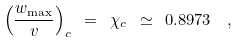Convert formula to latex. <formula><loc_0><loc_0><loc_500><loc_500>\left ( \frac { w _ { \max } } { v } \right ) _ { c } \ = \ \chi _ { c } \ \simeq \ 0 . 8 9 7 3 \ \ ,</formula> 